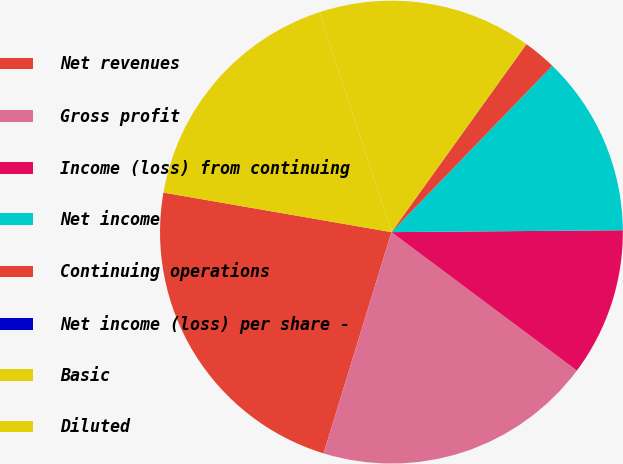Convert chart. <chart><loc_0><loc_0><loc_500><loc_500><pie_chart><fcel>Net revenues<fcel>Gross profit<fcel>Income (loss) from continuing<fcel>Net income<fcel>Continuing operations<fcel>Net income (loss) per share -<fcel>Basic<fcel>Diluted<nl><fcel>23.0%<fcel>19.53%<fcel>10.34%<fcel>12.64%<fcel>2.31%<fcel>0.01%<fcel>14.94%<fcel>17.24%<nl></chart> 